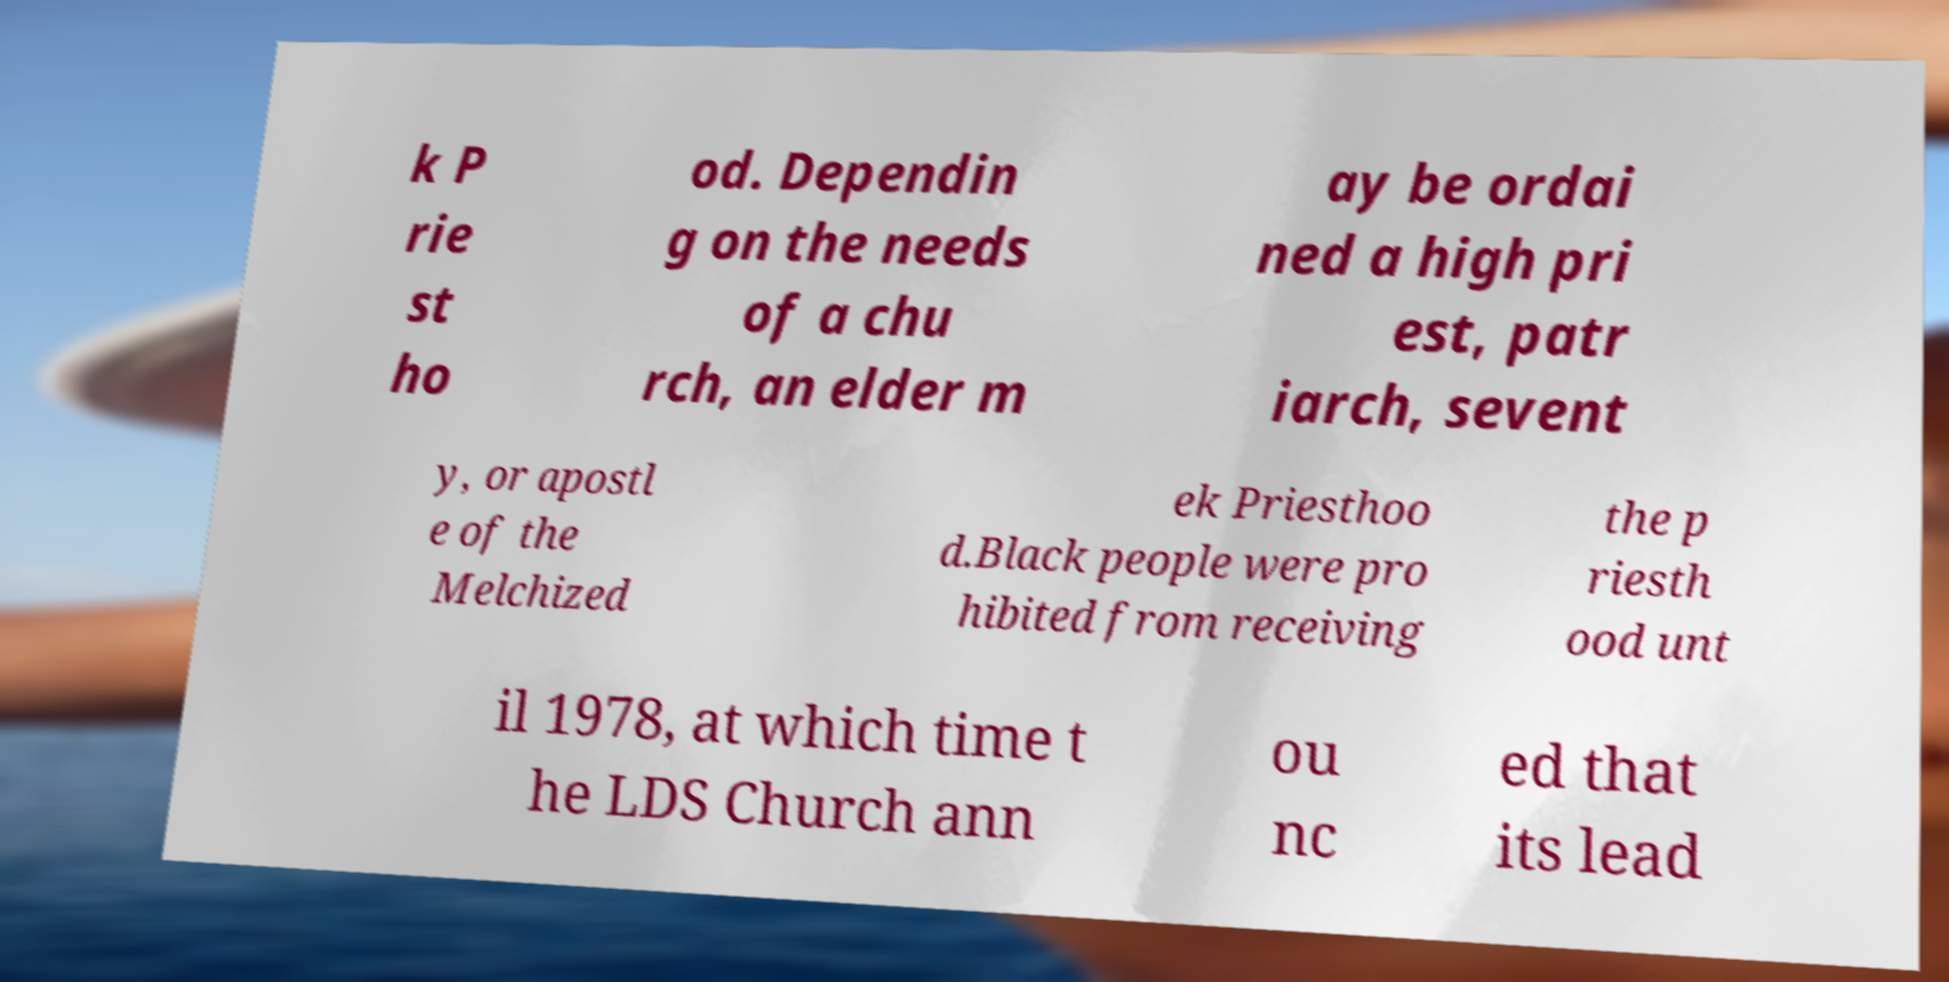I need the written content from this picture converted into text. Can you do that? k P rie st ho od. Dependin g on the needs of a chu rch, an elder m ay be ordai ned a high pri est, patr iarch, sevent y, or apostl e of the Melchized ek Priesthoo d.Black people were pro hibited from receiving the p riesth ood unt il 1978, at which time t he LDS Church ann ou nc ed that its lead 